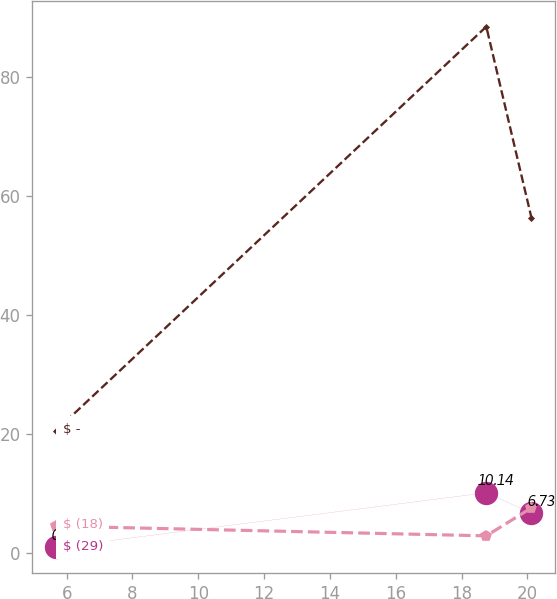Convert chart. <chart><loc_0><loc_0><loc_500><loc_500><line_chart><ecel><fcel>$ (29)<fcel>$ -<fcel>$ (18)<nl><fcel>5.68<fcel>0.95<fcel>20.61<fcel>4.53<nl><fcel>18.75<fcel>10.14<fcel>88.51<fcel>2.9<nl><fcel>20.12<fcel>6.73<fcel>56.42<fcel>7.6<nl></chart> 